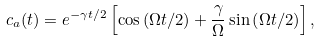Convert formula to latex. <formula><loc_0><loc_0><loc_500><loc_500>c _ { a } ( t ) = e ^ { - \gamma t / 2 } \left [ \cos \left ( \Omega t / 2 \right ) + \frac { \gamma } { \Omega } \sin \left ( \Omega t / 2 \right ) \right ] ,</formula> 